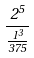Convert formula to latex. <formula><loc_0><loc_0><loc_500><loc_500>\frac { 2 ^ { 5 } } { \frac { 1 ^ { 3 } } { 3 7 5 } }</formula> 